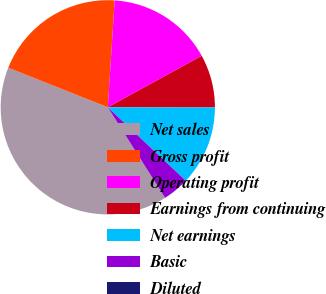<chart> <loc_0><loc_0><loc_500><loc_500><pie_chart><fcel>Net sales<fcel>Gross profit<fcel>Operating profit<fcel>Earnings from continuing<fcel>Net earnings<fcel>Basic<fcel>Diluted<nl><fcel>40.0%<fcel>20.0%<fcel>16.0%<fcel>8.0%<fcel>12.0%<fcel>4.0%<fcel>0.0%<nl></chart> 